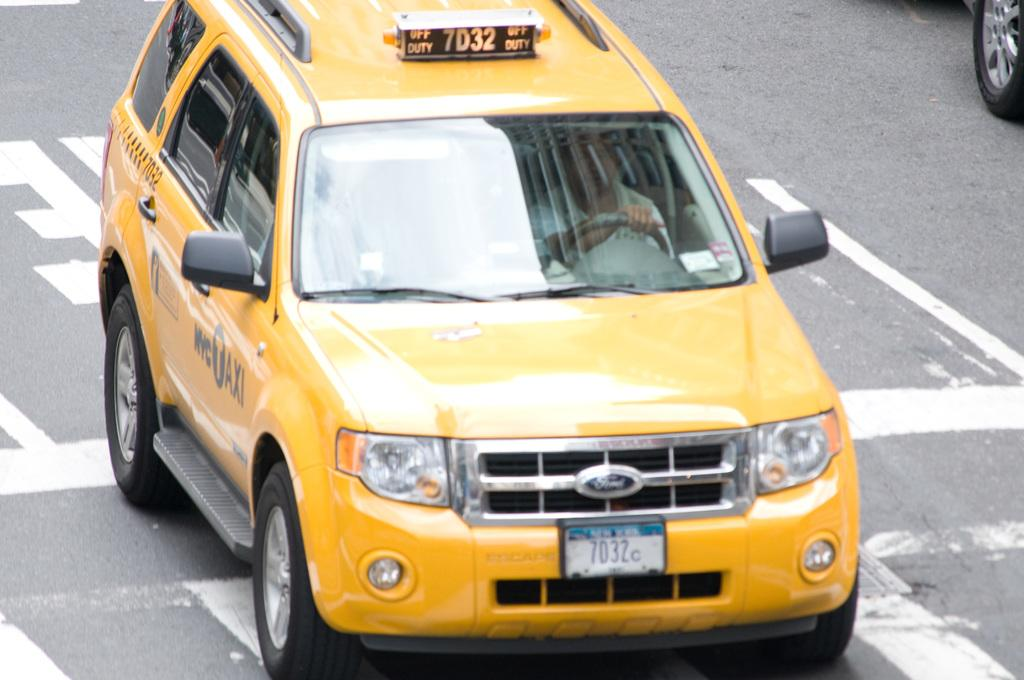<image>
Offer a succinct explanation of the picture presented. New York taxi number 7D32 is off duty 